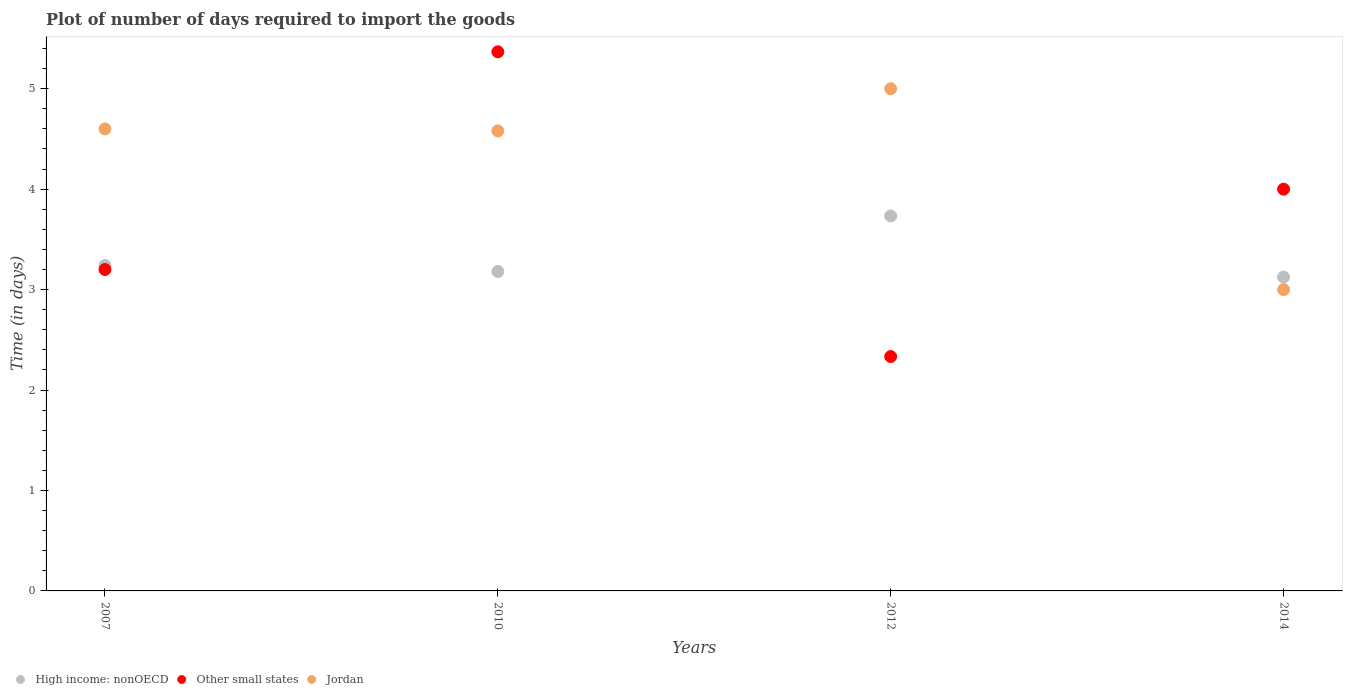How many different coloured dotlines are there?
Ensure brevity in your answer.  3. Across all years, what is the minimum time required to import goods in High income: nonOECD?
Your answer should be very brief. 3.12. In which year was the time required to import goods in Jordan minimum?
Your answer should be very brief. 2014. What is the total time required to import goods in High income: nonOECD in the graph?
Your answer should be very brief. 13.28. What is the difference between the time required to import goods in Other small states in 2010 and that in 2014?
Ensure brevity in your answer.  1.37. What is the difference between the time required to import goods in Jordan in 2010 and the time required to import goods in High income: nonOECD in 2007?
Keep it short and to the point. 1.34. What is the average time required to import goods in Jordan per year?
Make the answer very short. 4.29. In the year 2012, what is the difference between the time required to import goods in Other small states and time required to import goods in Jordan?
Make the answer very short. -2.67. In how many years, is the time required to import goods in High income: nonOECD greater than 4.2 days?
Your answer should be very brief. 0. What is the ratio of the time required to import goods in Jordan in 2007 to that in 2014?
Ensure brevity in your answer.  1.53. What is the difference between the highest and the second highest time required to import goods in Other small states?
Make the answer very short. 1.37. What is the difference between the highest and the lowest time required to import goods in High income: nonOECD?
Provide a short and direct response. 0.61. In how many years, is the time required to import goods in Other small states greater than the average time required to import goods in Other small states taken over all years?
Ensure brevity in your answer.  2. Does the time required to import goods in Other small states monotonically increase over the years?
Ensure brevity in your answer.  No. How many dotlines are there?
Your answer should be compact. 3. What is the difference between two consecutive major ticks on the Y-axis?
Keep it short and to the point. 1. Are the values on the major ticks of Y-axis written in scientific E-notation?
Provide a succinct answer. No. Where does the legend appear in the graph?
Give a very brief answer. Bottom left. How many legend labels are there?
Ensure brevity in your answer.  3. What is the title of the graph?
Your response must be concise. Plot of number of days required to import the goods. What is the label or title of the X-axis?
Keep it short and to the point. Years. What is the label or title of the Y-axis?
Give a very brief answer. Time (in days). What is the Time (in days) of High income: nonOECD in 2007?
Offer a very short reply. 3.24. What is the Time (in days) in Other small states in 2007?
Provide a succinct answer. 3.2. What is the Time (in days) of High income: nonOECD in 2010?
Give a very brief answer. 3.18. What is the Time (in days) in Other small states in 2010?
Your response must be concise. 5.37. What is the Time (in days) of Jordan in 2010?
Offer a terse response. 4.58. What is the Time (in days) of High income: nonOECD in 2012?
Keep it short and to the point. 3.73. What is the Time (in days) in Other small states in 2012?
Your answer should be compact. 2.33. What is the Time (in days) in High income: nonOECD in 2014?
Offer a very short reply. 3.12. What is the Time (in days) in Other small states in 2014?
Keep it short and to the point. 4. What is the Time (in days) in Jordan in 2014?
Keep it short and to the point. 3. Across all years, what is the maximum Time (in days) in High income: nonOECD?
Keep it short and to the point. 3.73. Across all years, what is the maximum Time (in days) in Other small states?
Keep it short and to the point. 5.37. Across all years, what is the maximum Time (in days) of Jordan?
Give a very brief answer. 5. Across all years, what is the minimum Time (in days) of High income: nonOECD?
Your response must be concise. 3.12. Across all years, what is the minimum Time (in days) of Other small states?
Keep it short and to the point. 2.33. What is the total Time (in days) in High income: nonOECD in the graph?
Your response must be concise. 13.28. What is the total Time (in days) in Other small states in the graph?
Your response must be concise. 14.9. What is the total Time (in days) of Jordan in the graph?
Provide a short and direct response. 17.18. What is the difference between the Time (in days) in Other small states in 2007 and that in 2010?
Keep it short and to the point. -2.17. What is the difference between the Time (in days) in Jordan in 2007 and that in 2010?
Give a very brief answer. 0.02. What is the difference between the Time (in days) of High income: nonOECD in 2007 and that in 2012?
Your response must be concise. -0.49. What is the difference between the Time (in days) of Other small states in 2007 and that in 2012?
Provide a short and direct response. 0.87. What is the difference between the Time (in days) in Jordan in 2007 and that in 2012?
Keep it short and to the point. -0.4. What is the difference between the Time (in days) of High income: nonOECD in 2007 and that in 2014?
Your response must be concise. 0.12. What is the difference between the Time (in days) in Jordan in 2007 and that in 2014?
Make the answer very short. 1.6. What is the difference between the Time (in days) in High income: nonOECD in 2010 and that in 2012?
Offer a very short reply. -0.55. What is the difference between the Time (in days) in Other small states in 2010 and that in 2012?
Offer a terse response. 3.03. What is the difference between the Time (in days) in Jordan in 2010 and that in 2012?
Your answer should be very brief. -0.42. What is the difference between the Time (in days) in High income: nonOECD in 2010 and that in 2014?
Provide a succinct answer. 0.06. What is the difference between the Time (in days) in Other small states in 2010 and that in 2014?
Ensure brevity in your answer.  1.37. What is the difference between the Time (in days) of Jordan in 2010 and that in 2014?
Provide a short and direct response. 1.58. What is the difference between the Time (in days) in High income: nonOECD in 2012 and that in 2014?
Your answer should be compact. 0.61. What is the difference between the Time (in days) of Other small states in 2012 and that in 2014?
Offer a very short reply. -1.67. What is the difference between the Time (in days) in High income: nonOECD in 2007 and the Time (in days) in Other small states in 2010?
Offer a terse response. -2.13. What is the difference between the Time (in days) of High income: nonOECD in 2007 and the Time (in days) of Jordan in 2010?
Your answer should be very brief. -1.34. What is the difference between the Time (in days) in Other small states in 2007 and the Time (in days) in Jordan in 2010?
Keep it short and to the point. -1.38. What is the difference between the Time (in days) in High income: nonOECD in 2007 and the Time (in days) in Other small states in 2012?
Make the answer very short. 0.91. What is the difference between the Time (in days) in High income: nonOECD in 2007 and the Time (in days) in Jordan in 2012?
Offer a terse response. -1.76. What is the difference between the Time (in days) of Other small states in 2007 and the Time (in days) of Jordan in 2012?
Ensure brevity in your answer.  -1.8. What is the difference between the Time (in days) of High income: nonOECD in 2007 and the Time (in days) of Other small states in 2014?
Keep it short and to the point. -0.76. What is the difference between the Time (in days) in High income: nonOECD in 2007 and the Time (in days) in Jordan in 2014?
Your response must be concise. 0.24. What is the difference between the Time (in days) in High income: nonOECD in 2010 and the Time (in days) in Other small states in 2012?
Your answer should be compact. 0.85. What is the difference between the Time (in days) of High income: nonOECD in 2010 and the Time (in days) of Jordan in 2012?
Keep it short and to the point. -1.82. What is the difference between the Time (in days) in Other small states in 2010 and the Time (in days) in Jordan in 2012?
Ensure brevity in your answer.  0.37. What is the difference between the Time (in days) in High income: nonOECD in 2010 and the Time (in days) in Other small states in 2014?
Your answer should be compact. -0.82. What is the difference between the Time (in days) of High income: nonOECD in 2010 and the Time (in days) of Jordan in 2014?
Offer a terse response. 0.18. What is the difference between the Time (in days) of Other small states in 2010 and the Time (in days) of Jordan in 2014?
Offer a very short reply. 2.37. What is the difference between the Time (in days) in High income: nonOECD in 2012 and the Time (in days) in Other small states in 2014?
Give a very brief answer. -0.27. What is the difference between the Time (in days) in High income: nonOECD in 2012 and the Time (in days) in Jordan in 2014?
Your response must be concise. 0.73. What is the average Time (in days) in High income: nonOECD per year?
Make the answer very short. 3.32. What is the average Time (in days) of Other small states per year?
Ensure brevity in your answer.  3.73. What is the average Time (in days) in Jordan per year?
Make the answer very short. 4.29. In the year 2007, what is the difference between the Time (in days) of High income: nonOECD and Time (in days) of Jordan?
Offer a terse response. -1.36. In the year 2007, what is the difference between the Time (in days) of Other small states and Time (in days) of Jordan?
Your answer should be compact. -1.4. In the year 2010, what is the difference between the Time (in days) of High income: nonOECD and Time (in days) of Other small states?
Make the answer very short. -2.19. In the year 2010, what is the difference between the Time (in days) of High income: nonOECD and Time (in days) of Jordan?
Offer a very short reply. -1.4. In the year 2010, what is the difference between the Time (in days) in Other small states and Time (in days) in Jordan?
Offer a terse response. 0.79. In the year 2012, what is the difference between the Time (in days) in High income: nonOECD and Time (in days) in Other small states?
Provide a succinct answer. 1.4. In the year 2012, what is the difference between the Time (in days) in High income: nonOECD and Time (in days) in Jordan?
Offer a terse response. -1.27. In the year 2012, what is the difference between the Time (in days) of Other small states and Time (in days) of Jordan?
Ensure brevity in your answer.  -2.67. In the year 2014, what is the difference between the Time (in days) in High income: nonOECD and Time (in days) in Other small states?
Provide a short and direct response. -0.88. What is the ratio of the Time (in days) of High income: nonOECD in 2007 to that in 2010?
Provide a succinct answer. 1.02. What is the ratio of the Time (in days) in Other small states in 2007 to that in 2010?
Your response must be concise. 0.6. What is the ratio of the Time (in days) of Jordan in 2007 to that in 2010?
Offer a very short reply. 1. What is the ratio of the Time (in days) of High income: nonOECD in 2007 to that in 2012?
Ensure brevity in your answer.  0.87. What is the ratio of the Time (in days) of Other small states in 2007 to that in 2012?
Ensure brevity in your answer.  1.37. What is the ratio of the Time (in days) of High income: nonOECD in 2007 to that in 2014?
Provide a short and direct response. 1.04. What is the ratio of the Time (in days) in Other small states in 2007 to that in 2014?
Give a very brief answer. 0.8. What is the ratio of the Time (in days) in Jordan in 2007 to that in 2014?
Offer a terse response. 1.53. What is the ratio of the Time (in days) in High income: nonOECD in 2010 to that in 2012?
Your response must be concise. 0.85. What is the ratio of the Time (in days) in Other small states in 2010 to that in 2012?
Your response must be concise. 2.3. What is the ratio of the Time (in days) of Jordan in 2010 to that in 2012?
Ensure brevity in your answer.  0.92. What is the ratio of the Time (in days) in High income: nonOECD in 2010 to that in 2014?
Your response must be concise. 1.02. What is the ratio of the Time (in days) in Other small states in 2010 to that in 2014?
Offer a very short reply. 1.34. What is the ratio of the Time (in days) in Jordan in 2010 to that in 2014?
Your answer should be very brief. 1.53. What is the ratio of the Time (in days) of High income: nonOECD in 2012 to that in 2014?
Offer a very short reply. 1.19. What is the ratio of the Time (in days) in Other small states in 2012 to that in 2014?
Your response must be concise. 0.58. What is the difference between the highest and the second highest Time (in days) in High income: nonOECD?
Ensure brevity in your answer.  0.49. What is the difference between the highest and the second highest Time (in days) of Other small states?
Your answer should be very brief. 1.37. What is the difference between the highest and the lowest Time (in days) of High income: nonOECD?
Your answer should be compact. 0.61. What is the difference between the highest and the lowest Time (in days) in Other small states?
Offer a terse response. 3.03. 